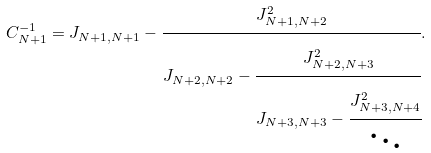Convert formula to latex. <formula><loc_0><loc_0><loc_500><loc_500>C _ { N + 1 } ^ { - 1 } = { J _ { N + 1 , N + 1 } - \cfrac { J _ { N + 1 , N + 2 } ^ { 2 } } { J _ { N + 2 , N + 2 } - \cfrac { J _ { N + 2 , N + 3 } ^ { 2 } } { J _ { N + 3 , N + 3 } - \cfrac { J _ { N + 3 , N + 4 } ^ { 2 } } { \ddots } } } } .</formula> 